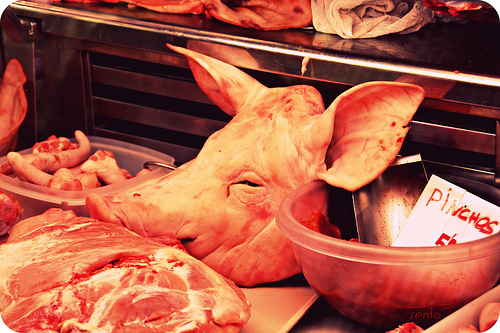<image>
Can you confirm if the pig is on the counter? Yes. Looking at the image, I can see the pig is positioned on top of the counter, with the counter providing support. 